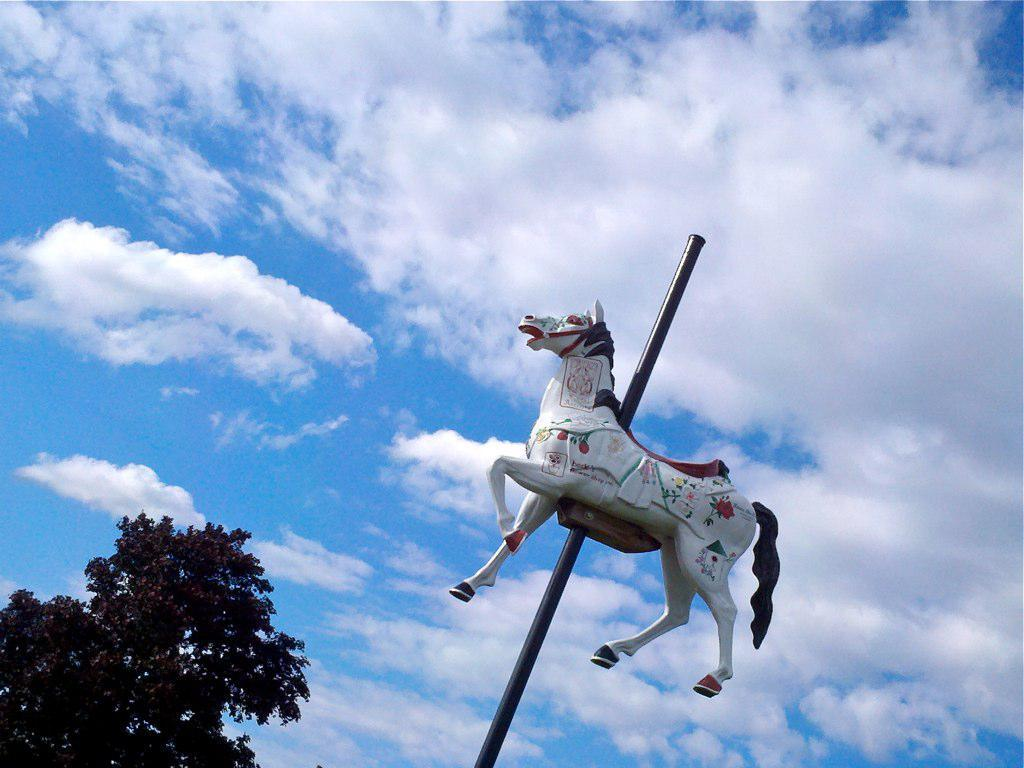What is attached to the pole in the image? There is a toy horse attached to the pole in the image. What type of plant can be seen in the image? There is a tree in the image. What can be seen in the background of the image? The sky is visible in the background of the image. Can you see any eggs on the seashore in the image? There is no seashore or eggs present in the image. What type of rod is being used to catch fish in the image? There is no rod or fishing activity depicted in the image. 